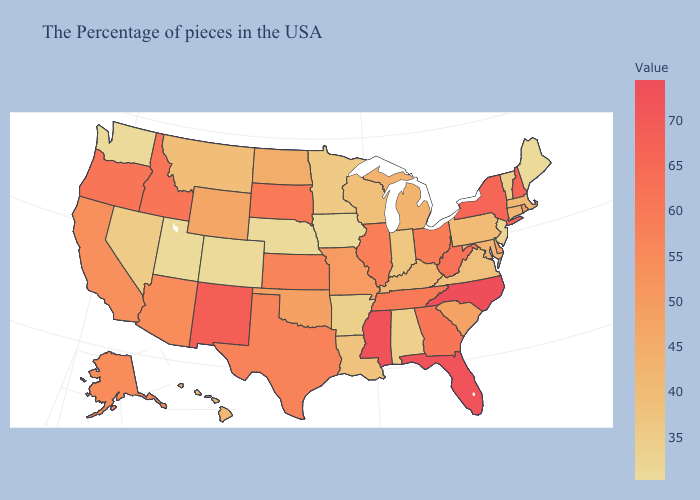Does Missouri have a lower value than Washington?
Answer briefly. No. Does Missouri have a lower value than Nevada?
Quick response, please. No. Which states have the highest value in the USA?
Be succinct. North Carolina. Is the legend a continuous bar?
Concise answer only. Yes. 